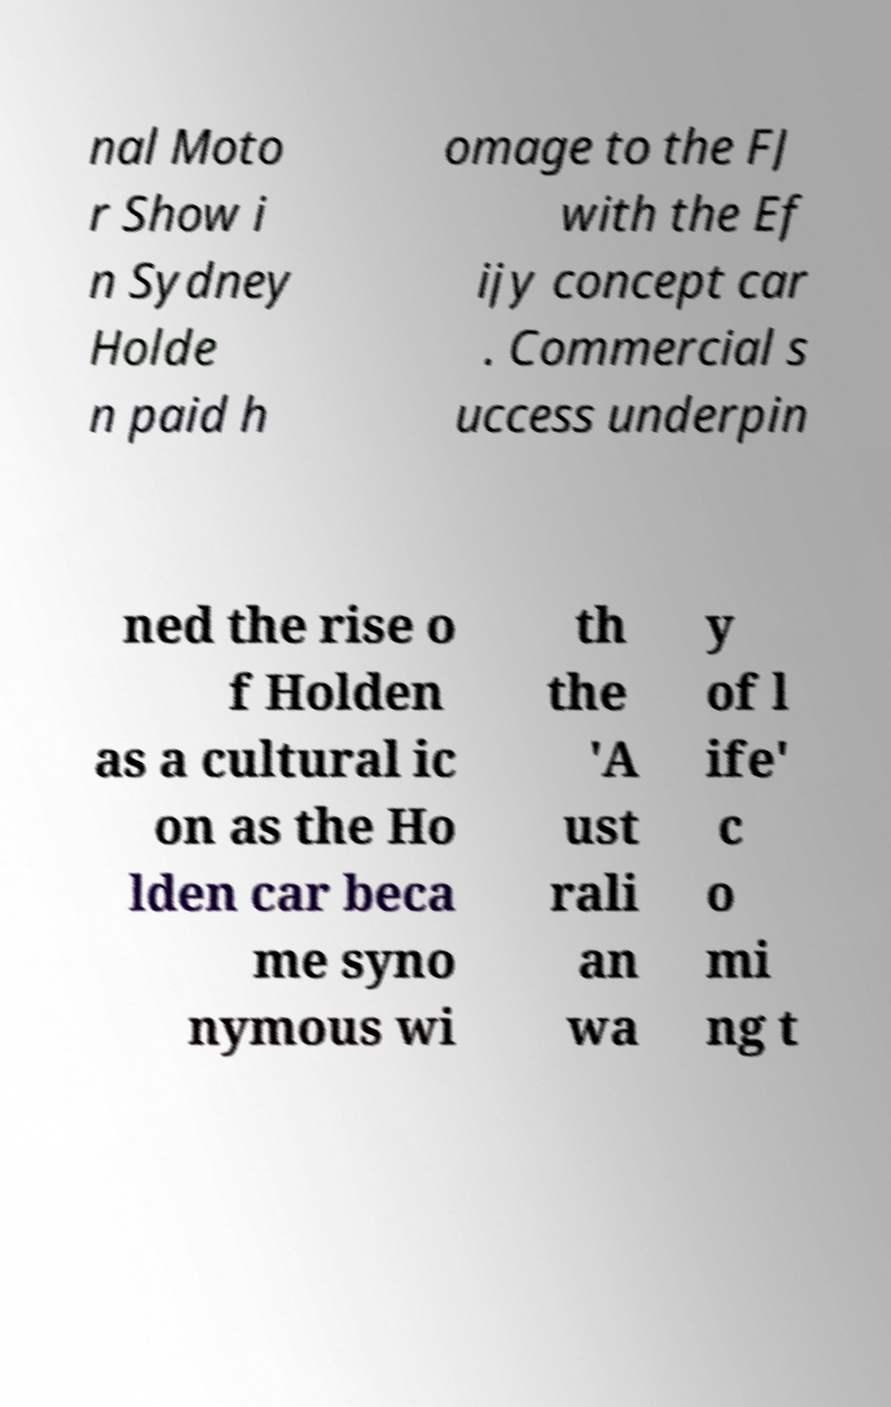For documentation purposes, I need the text within this image transcribed. Could you provide that? nal Moto r Show i n Sydney Holde n paid h omage to the FJ with the Ef ijy concept car . Commercial s uccess underpin ned the rise o f Holden as a cultural ic on as the Ho lden car beca me syno nymous wi th the 'A ust rali an wa y of l ife' c o mi ng t 